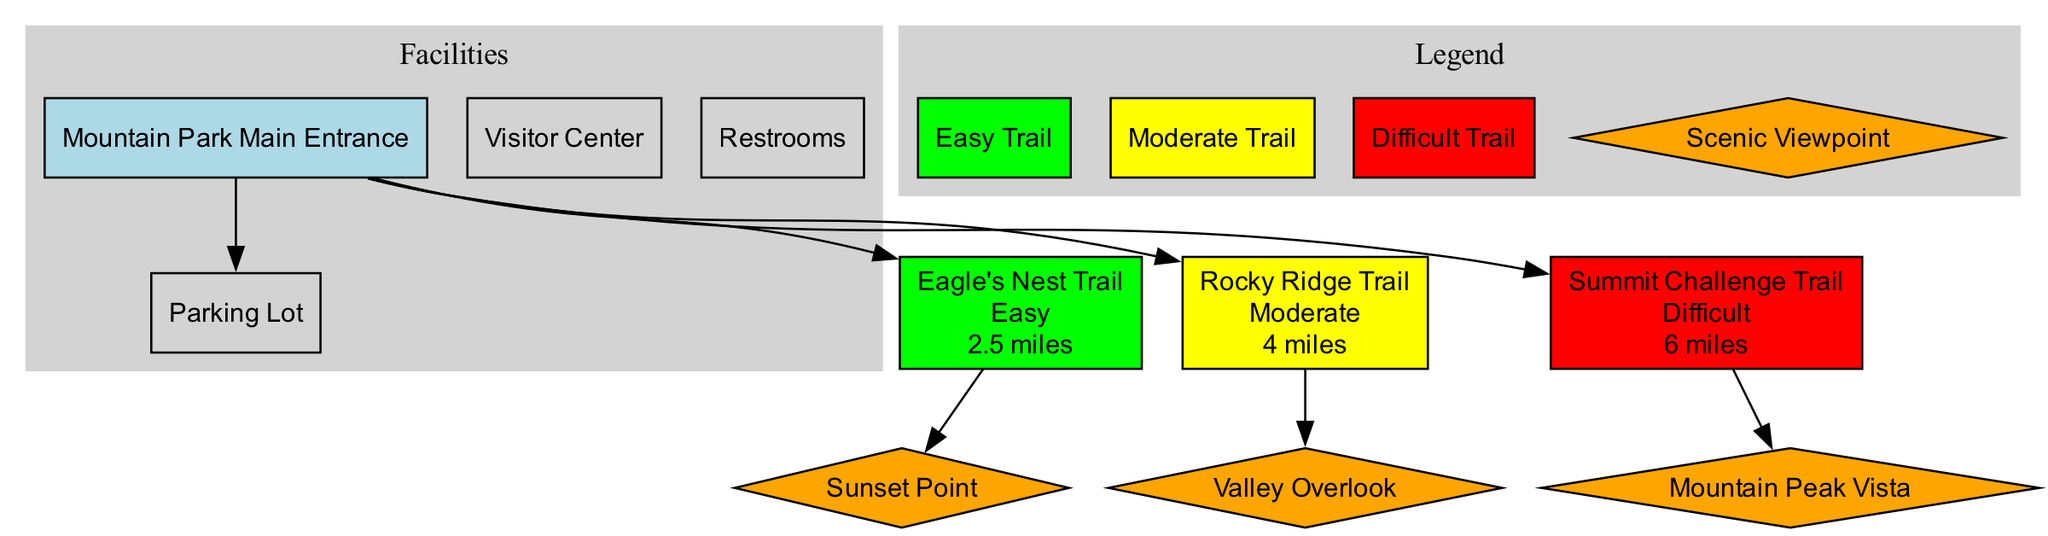What is the difficulty level of the Eagle's Nest Trail? The Eagle's Nest Trail, as indicated in the diagram, has the difficulty listed right next to its name in the trail section. It states "Easy".
Answer: Easy How many scenic viewpoints are there in total? The diagram lists three scenic viewpoints, each clearly connecting to its respective trail. They are Sunset Point, Valley Overlook, and Mountain Peak Vista.
Answer: 3 Which trail is associated with the Valley Overlook viewpoint? The Valley Overlook viewpoint is connected directly to the Rocky Ridge Trail in the diagram, as indicated by their relationship shown with an edge.
Answer: Rocky Ridge Trail What color represents the difficult trails in the diagram? The difficult trails are represented by a red color filled node. This is established in the colors section concerning trails marked by their difficulty.
Answer: Red How long is the Summit Challenge Trail? The length information for the Summit Challenge Trail is provided directly below its name in the diagram. It indicates that its length is "6 miles".
Answer: 6 miles Which facility is directly connected to the park entrance? The diagram shows that the Parking Lot is directly connected to the park entrance through an edge, which indicates a clear relationship.
Answer: Parking Lot What is the total length of all trails combined? The lengths of each of the three trails are provided: 2.5 miles (Eagle's Nest), 4 miles (Rocky Ridge), and 6 miles (Summit Challenge). Adding them gives a total of 12.5 miles.
Answer: 12.5 miles What type of shape is used to represent scenic viewpoints? The scenic viewpoints, as specified in the diagram, are represented using a diamond shape, as indicated by the shape attribute for these nodes.
Answer: Diamond Which viewpoint is located on the Eagle's Nest Trail? The diagram specifies that Sunset Point is the viewpoint located on the Eagle's Nest Trail, as seen from the direct relationship shown in the diagram.
Answer: Sunset Point 